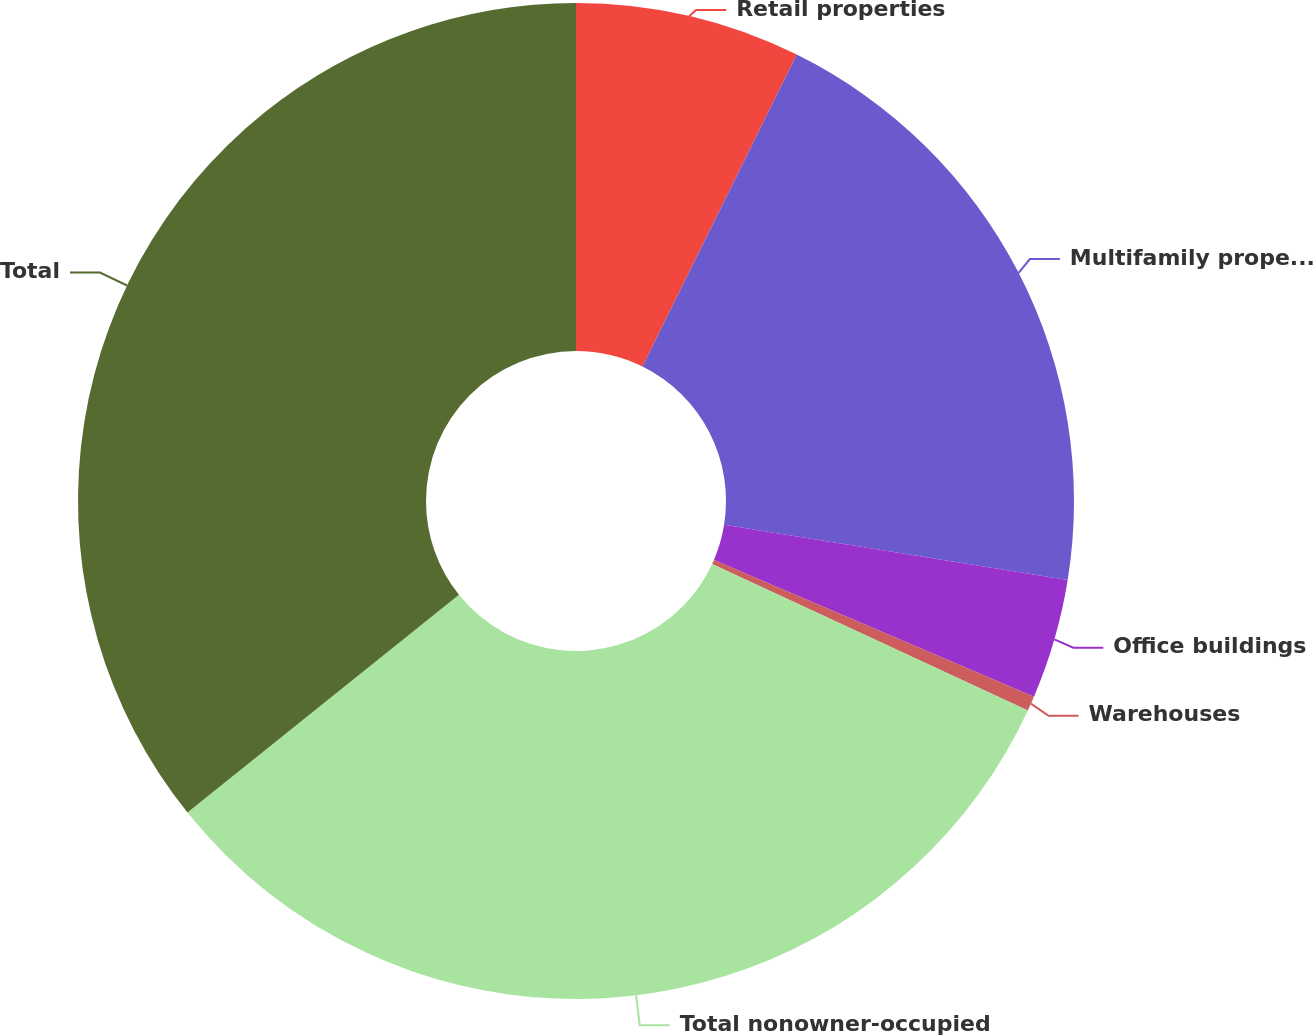Convert chart to OTSL. <chart><loc_0><loc_0><loc_500><loc_500><pie_chart><fcel>Retail properties<fcel>Multifamily properties<fcel>Office buildings<fcel>Warehouses<fcel>Total nonowner-occupied<fcel>Total<nl><fcel>7.31%<fcel>20.23%<fcel>3.89%<fcel>0.48%<fcel>32.34%<fcel>35.76%<nl></chart> 